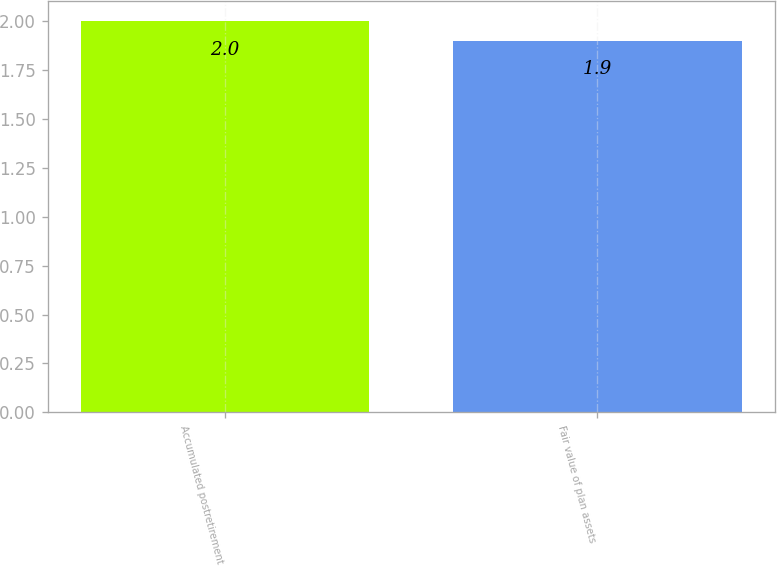<chart> <loc_0><loc_0><loc_500><loc_500><bar_chart><fcel>Accumulated postretirement<fcel>Fair value of plan assets<nl><fcel>2<fcel>1.9<nl></chart> 